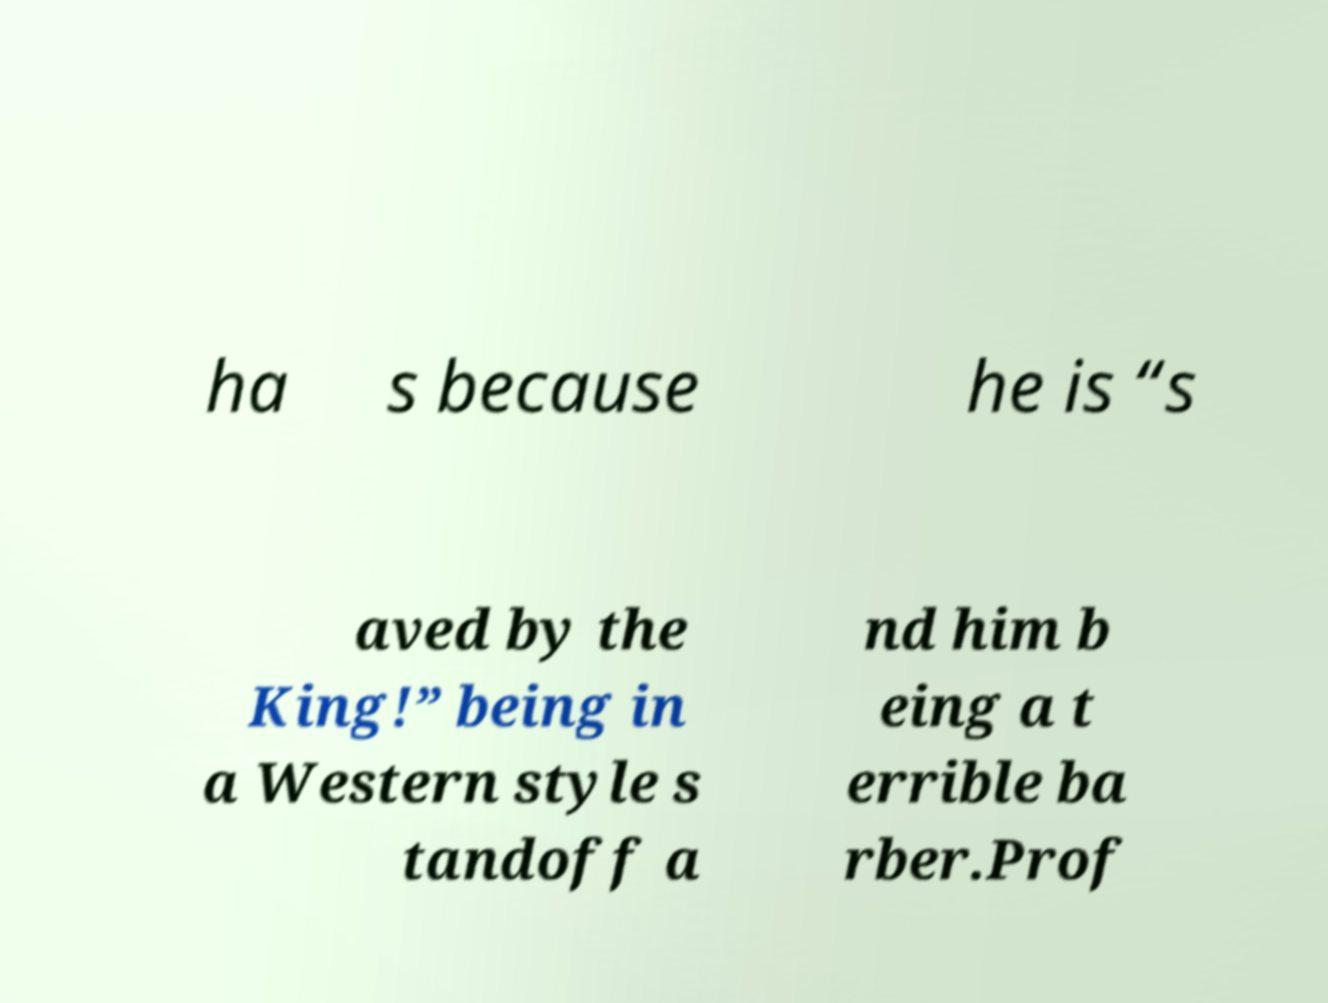I need the written content from this picture converted into text. Can you do that? ha s because he is “s aved by the King!” being in a Western style s tandoff a nd him b eing a t errible ba rber.Prof 